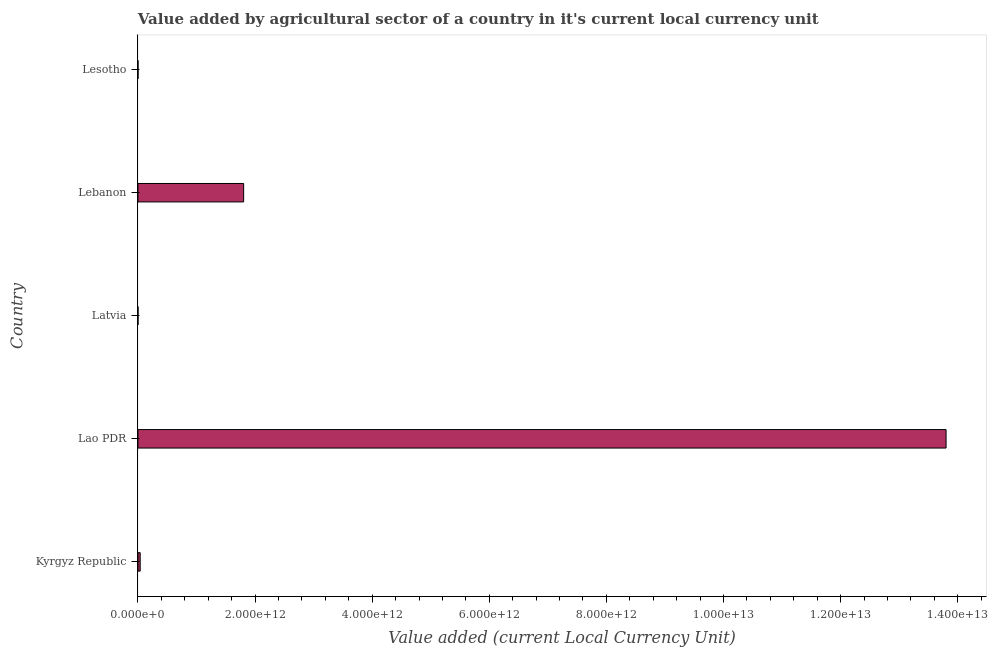Does the graph contain any zero values?
Make the answer very short. No. Does the graph contain grids?
Give a very brief answer. No. What is the title of the graph?
Your answer should be compact. Value added by agricultural sector of a country in it's current local currency unit. What is the label or title of the X-axis?
Give a very brief answer. Value added (current Local Currency Unit). What is the label or title of the Y-axis?
Your response must be concise. Country. What is the value added by agriculture sector in Kyrgyz Republic?
Your response must be concise. 3.81e+1. Across all countries, what is the maximum value added by agriculture sector?
Your answer should be compact. 1.38e+13. Across all countries, what is the minimum value added by agriculture sector?
Give a very brief answer. 7.51e+08. In which country was the value added by agriculture sector maximum?
Provide a succinct answer. Lao PDR. In which country was the value added by agriculture sector minimum?
Offer a very short reply. Latvia. What is the sum of the value added by agriculture sector?
Your answer should be very brief. 1.56e+13. What is the difference between the value added by agriculture sector in Kyrgyz Republic and Latvia?
Your answer should be very brief. 3.74e+1. What is the average value added by agriculture sector per country?
Offer a terse response. 3.13e+12. What is the median value added by agriculture sector?
Your answer should be compact. 3.81e+1. Is the value added by agriculture sector in Lao PDR less than that in Lesotho?
Keep it short and to the point. No. What is the difference between the highest and the second highest value added by agriculture sector?
Ensure brevity in your answer.  1.20e+13. What is the difference between the highest and the lowest value added by agriculture sector?
Offer a very short reply. 1.38e+13. In how many countries, is the value added by agriculture sector greater than the average value added by agriculture sector taken over all countries?
Your answer should be compact. 1. How many bars are there?
Give a very brief answer. 5. How many countries are there in the graph?
Offer a terse response. 5. What is the difference between two consecutive major ticks on the X-axis?
Give a very brief answer. 2.00e+12. What is the Value added (current Local Currency Unit) of Kyrgyz Republic?
Keep it short and to the point. 3.81e+1. What is the Value added (current Local Currency Unit) of Lao PDR?
Ensure brevity in your answer.  1.38e+13. What is the Value added (current Local Currency Unit) in Latvia?
Give a very brief answer. 7.51e+08. What is the Value added (current Local Currency Unit) of Lebanon?
Your response must be concise. 1.80e+12. What is the Value added (current Local Currency Unit) in Lesotho?
Offer a terse response. 7.90e+08. What is the difference between the Value added (current Local Currency Unit) in Kyrgyz Republic and Lao PDR?
Provide a succinct answer. -1.38e+13. What is the difference between the Value added (current Local Currency Unit) in Kyrgyz Republic and Latvia?
Provide a short and direct response. 3.74e+1. What is the difference between the Value added (current Local Currency Unit) in Kyrgyz Republic and Lebanon?
Give a very brief answer. -1.77e+12. What is the difference between the Value added (current Local Currency Unit) in Kyrgyz Republic and Lesotho?
Give a very brief answer. 3.74e+1. What is the difference between the Value added (current Local Currency Unit) in Lao PDR and Latvia?
Provide a short and direct response. 1.38e+13. What is the difference between the Value added (current Local Currency Unit) in Lao PDR and Lebanon?
Offer a terse response. 1.20e+13. What is the difference between the Value added (current Local Currency Unit) in Lao PDR and Lesotho?
Offer a terse response. 1.38e+13. What is the difference between the Value added (current Local Currency Unit) in Latvia and Lebanon?
Your answer should be very brief. -1.80e+12. What is the difference between the Value added (current Local Currency Unit) in Latvia and Lesotho?
Ensure brevity in your answer.  -3.95e+07. What is the difference between the Value added (current Local Currency Unit) in Lebanon and Lesotho?
Keep it short and to the point. 1.80e+12. What is the ratio of the Value added (current Local Currency Unit) in Kyrgyz Republic to that in Lao PDR?
Your answer should be compact. 0. What is the ratio of the Value added (current Local Currency Unit) in Kyrgyz Republic to that in Latvia?
Your response must be concise. 50.8. What is the ratio of the Value added (current Local Currency Unit) in Kyrgyz Republic to that in Lebanon?
Give a very brief answer. 0.02. What is the ratio of the Value added (current Local Currency Unit) in Kyrgyz Republic to that in Lesotho?
Provide a short and direct response. 48.26. What is the ratio of the Value added (current Local Currency Unit) in Lao PDR to that in Latvia?
Keep it short and to the point. 1.84e+04. What is the ratio of the Value added (current Local Currency Unit) in Lao PDR to that in Lebanon?
Ensure brevity in your answer.  7.65. What is the ratio of the Value added (current Local Currency Unit) in Lao PDR to that in Lesotho?
Ensure brevity in your answer.  1.75e+04. What is the ratio of the Value added (current Local Currency Unit) in Latvia to that in Lesotho?
Your answer should be compact. 0.95. What is the ratio of the Value added (current Local Currency Unit) in Lebanon to that in Lesotho?
Your response must be concise. 2283.82. 